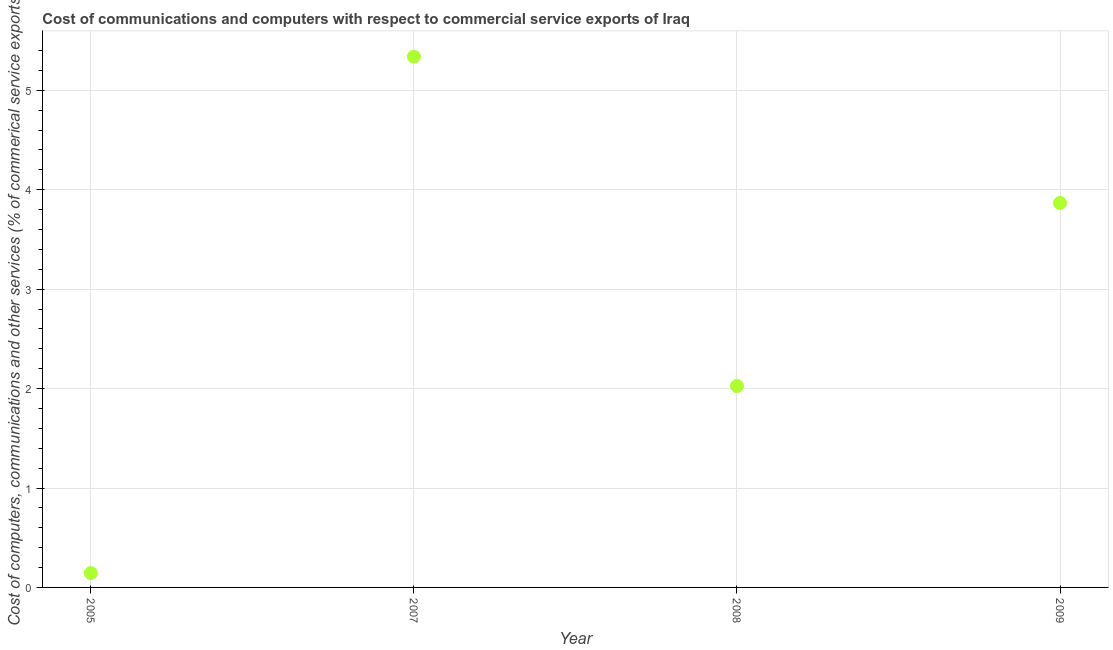What is the  computer and other services in 2005?
Your response must be concise. 0.14. Across all years, what is the maximum  computer and other services?
Provide a short and direct response. 5.34. Across all years, what is the minimum cost of communications?
Your answer should be very brief. 0.14. In which year was the cost of communications maximum?
Offer a terse response. 2007. What is the sum of the cost of communications?
Provide a short and direct response. 11.37. What is the difference between the  computer and other services in 2005 and 2007?
Your answer should be compact. -5.19. What is the average  computer and other services per year?
Make the answer very short. 2.84. What is the median  computer and other services?
Your answer should be very brief. 2.95. Do a majority of the years between 2005 and 2009 (inclusive) have cost of communications greater than 5 %?
Keep it short and to the point. No. What is the ratio of the cost of communications in 2007 to that in 2009?
Keep it short and to the point. 1.38. What is the difference between the highest and the second highest  computer and other services?
Ensure brevity in your answer.  1.47. Is the sum of the cost of communications in 2005 and 2007 greater than the maximum cost of communications across all years?
Your response must be concise. Yes. What is the difference between the highest and the lowest cost of communications?
Provide a succinct answer. 5.19. In how many years, is the  computer and other services greater than the average  computer and other services taken over all years?
Provide a short and direct response. 2. Does the  computer and other services monotonically increase over the years?
Your response must be concise. No. How many years are there in the graph?
Your answer should be very brief. 4. What is the difference between two consecutive major ticks on the Y-axis?
Offer a very short reply. 1. Does the graph contain any zero values?
Give a very brief answer. No. Does the graph contain grids?
Your response must be concise. Yes. What is the title of the graph?
Give a very brief answer. Cost of communications and computers with respect to commercial service exports of Iraq. What is the label or title of the Y-axis?
Provide a short and direct response. Cost of computers, communications and other services (% of commerical service exports). What is the Cost of computers, communications and other services (% of commerical service exports) in 2005?
Keep it short and to the point. 0.14. What is the Cost of computers, communications and other services (% of commerical service exports) in 2007?
Offer a terse response. 5.34. What is the Cost of computers, communications and other services (% of commerical service exports) in 2008?
Offer a very short reply. 2.03. What is the Cost of computers, communications and other services (% of commerical service exports) in 2009?
Your answer should be very brief. 3.87. What is the difference between the Cost of computers, communications and other services (% of commerical service exports) in 2005 and 2007?
Make the answer very short. -5.19. What is the difference between the Cost of computers, communications and other services (% of commerical service exports) in 2005 and 2008?
Ensure brevity in your answer.  -1.88. What is the difference between the Cost of computers, communications and other services (% of commerical service exports) in 2005 and 2009?
Your answer should be compact. -3.72. What is the difference between the Cost of computers, communications and other services (% of commerical service exports) in 2007 and 2008?
Provide a succinct answer. 3.31. What is the difference between the Cost of computers, communications and other services (% of commerical service exports) in 2007 and 2009?
Offer a very short reply. 1.47. What is the difference between the Cost of computers, communications and other services (% of commerical service exports) in 2008 and 2009?
Ensure brevity in your answer.  -1.84. What is the ratio of the Cost of computers, communications and other services (% of commerical service exports) in 2005 to that in 2007?
Offer a terse response. 0.03. What is the ratio of the Cost of computers, communications and other services (% of commerical service exports) in 2005 to that in 2008?
Offer a terse response. 0.07. What is the ratio of the Cost of computers, communications and other services (% of commerical service exports) in 2005 to that in 2009?
Your answer should be compact. 0.04. What is the ratio of the Cost of computers, communications and other services (% of commerical service exports) in 2007 to that in 2008?
Make the answer very short. 2.63. What is the ratio of the Cost of computers, communications and other services (% of commerical service exports) in 2007 to that in 2009?
Your answer should be compact. 1.38. What is the ratio of the Cost of computers, communications and other services (% of commerical service exports) in 2008 to that in 2009?
Your answer should be very brief. 0.52. 